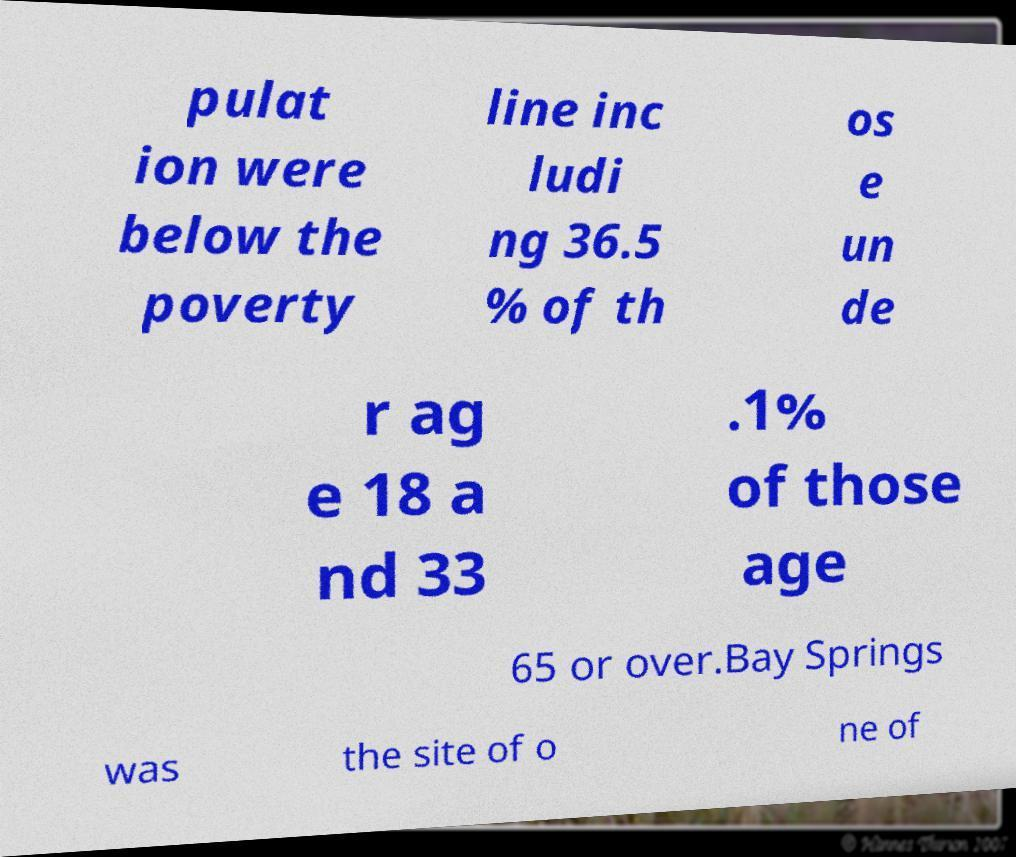For documentation purposes, I need the text within this image transcribed. Could you provide that? pulat ion were below the poverty line inc ludi ng 36.5 % of th os e un de r ag e 18 a nd 33 .1% of those age 65 or over.Bay Springs was the site of o ne of 